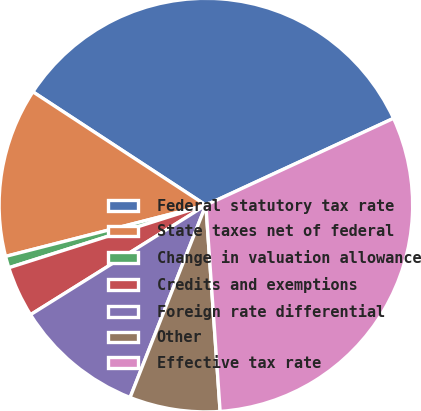Convert chart to OTSL. <chart><loc_0><loc_0><loc_500><loc_500><pie_chart><fcel>Federal statutory tax rate<fcel>State taxes net of federal<fcel>Change in valuation allowance<fcel>Credits and exemptions<fcel>Foreign rate differential<fcel>Other<fcel>Effective tax rate<nl><fcel>33.88%<fcel>13.22%<fcel>0.91%<fcel>3.99%<fcel>10.14%<fcel>7.07%<fcel>30.8%<nl></chart> 